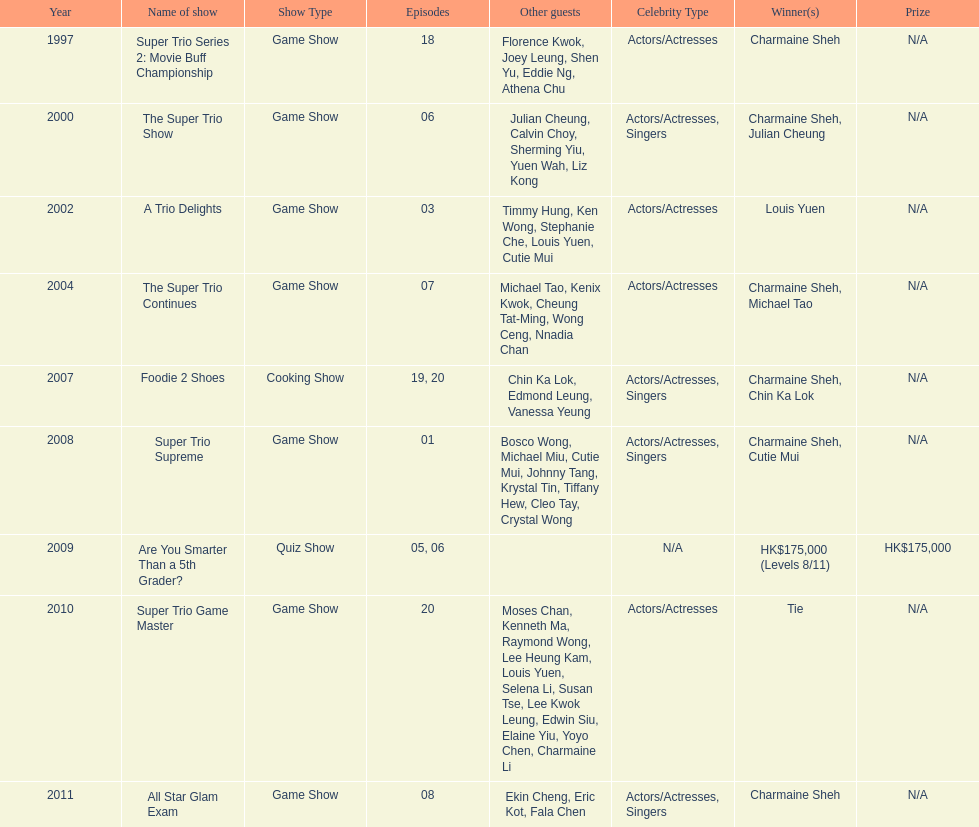What is the number of tv shows that charmaine sheh has appeared on? 9. 